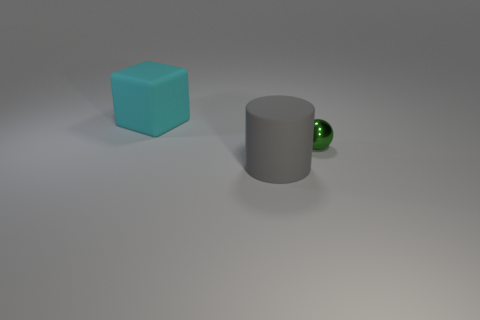There is a large object behind the big matte cylinder that is to the left of the green shiny sphere; what number of green metal things are in front of it?
Offer a very short reply. 1. What number of spheres are on the right side of the gray matte cylinder?
Your answer should be compact. 1. The large object that is in front of the big matte thing behind the tiny green metal sphere is what color?
Offer a very short reply. Gray. How many other objects are the same material as the big cyan block?
Keep it short and to the point. 1. Are there the same number of large cyan matte cubes to the right of the green object and green things?
Keep it short and to the point. No. What material is the thing that is left of the large thing on the right side of the big thing that is behind the small object made of?
Offer a very short reply. Rubber. What is the color of the large object in front of the small metal thing?
Provide a succinct answer. Gray. Is there any other thing that has the same shape as the metal object?
Your answer should be compact. No. What is the size of the matte thing behind the large rubber thing that is right of the large cyan rubber cube?
Provide a succinct answer. Large. Are there an equal number of things that are to the left of the big gray cylinder and cyan objects that are in front of the big cyan rubber cube?
Keep it short and to the point. No. 